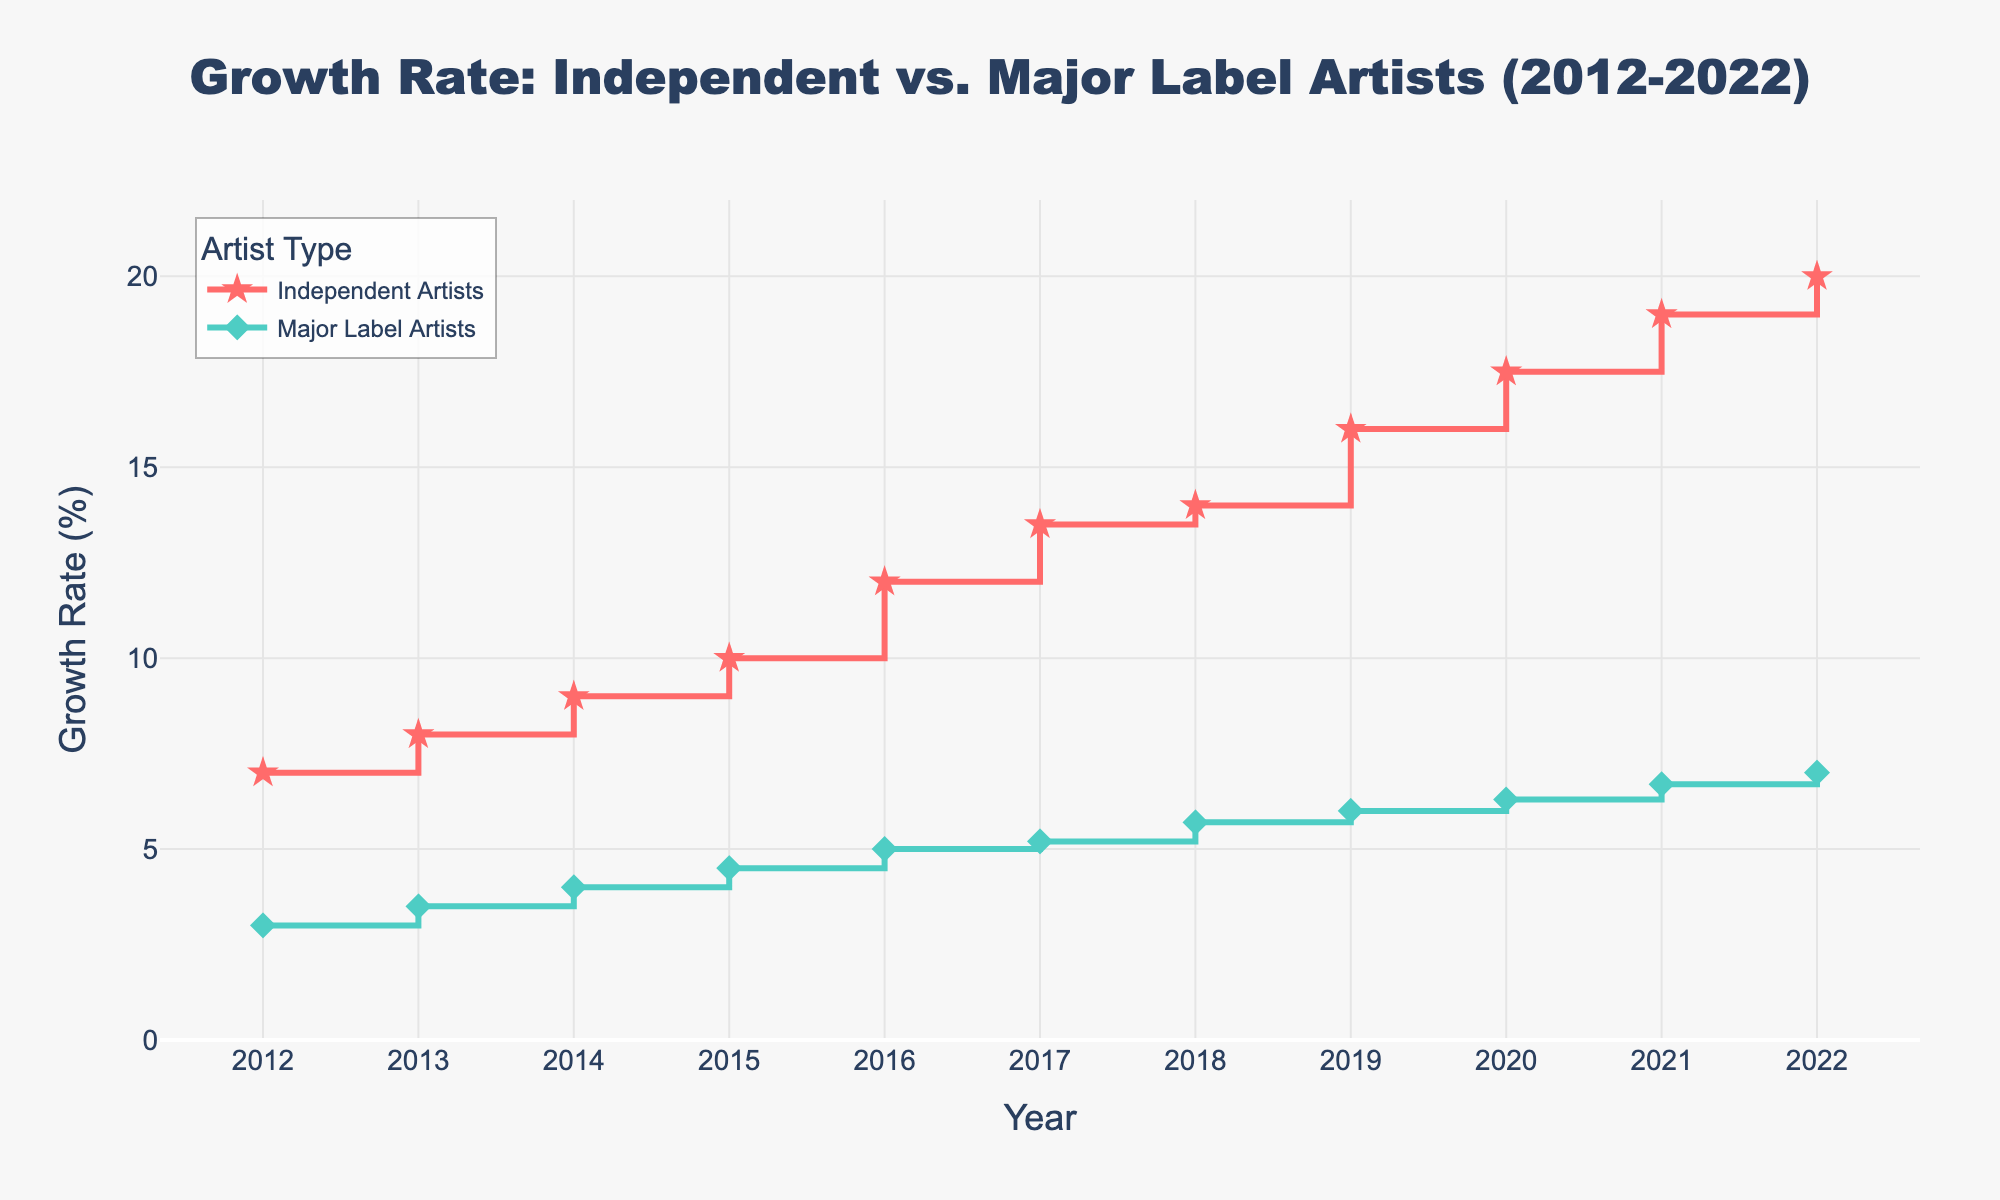what is the title of the plot? The title is located at the top center of the plot and reads "Growth Rate: Independent vs. Major Label Artists (2012-2022)."
Answer: Growth Rate: Independent vs. Major Label Artists (2012-2022) what are the colors used for independent artists and major label artists lines? The lines for Independent Artists are in red, while the Major Label Artists lines are in teal.
Answer: Red and teal how many years are represented in the plot? The x-axis of the plot contains 11 ticks, starting from 2012 and ending in 2022, representing 11 years.
Answer: 11 what is the highest growth rate reached by independent artists and in which year? The highest growth rate for Independent Artists is 20%, which is reached in the year 2022, as seen at the top of their stair plot line.
Answer: 20% in 2022 between which years did major label artists have their lowest growth rate? The lowest growth rate for Major Label Artists is 3%, which occurred in the year 2012. The next point is 3.5% in 2013, making 2012 the lowest year.
Answer: 2012 how much did the growth rate of independent artists change from 2015 to 2016? In 2015, the growth rate is 10% and in 2016, it is 12%. The change is calculated as 12% - 10% = 2%.
Answer: 2% in which year do both independent artists and major label artists show the same growth rate? By visually inspecting the plot, there is no year where both the Independent and Major Label Artists have the same growth rate; their lines never intersect.
Answer: None which year saw the largest year-on-year growth increase for independent artists? The largest year-on-year increase for Independent Artists occurs between 2019 and 2020, going from 16% to 17.5%, which is a 1.5% increase.
Answer: 2019 to 2020 how does the trend of growth rates differ between independent artists and major label artists? The trend for Independent Artists shows a sharper and more continuous increase over time, whereas Major Label Artists have a steadier and more gradual growth. This can be observed by the steeper slope of the Independent Artists' stair plot line compared to Major Label Artists.
Answer: Independent Artists show a sharper increase compared to Major Label Artists 